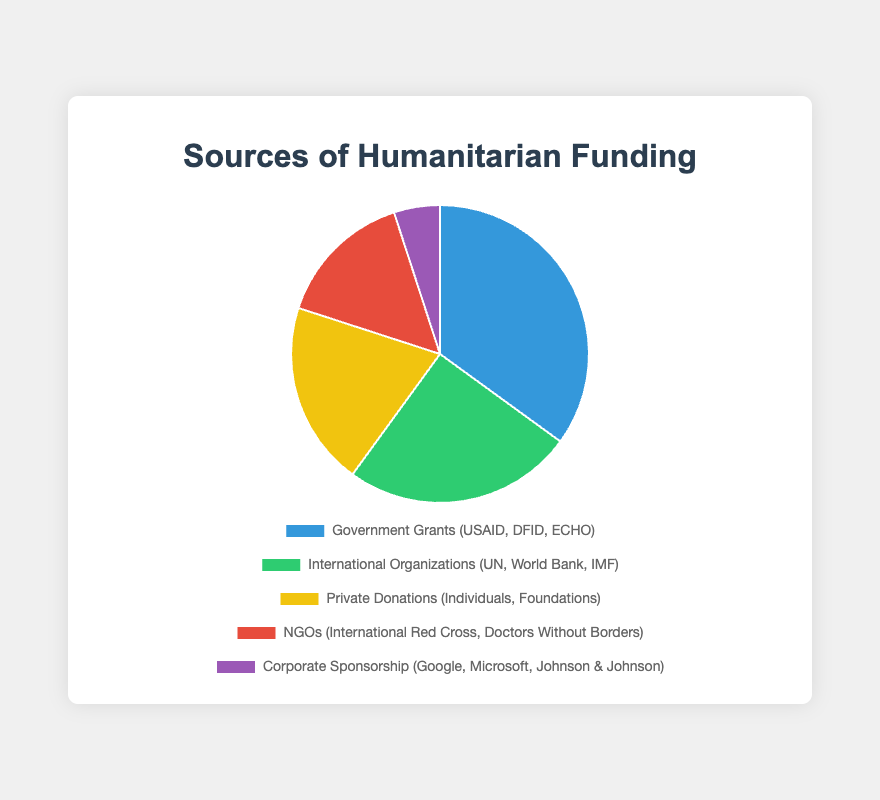Which funding source contributes the largest percentage? Based on the pie chart, look for the section with the largest portion. It's labeled as "Government Grants (USAID, DFID, ECHO)" with 35%.
Answer: Government Grants Which two funding sources combined contribute exactly half of the total funding? Adding the percentages of the two largest sections, "Government Grants (35%)" and "International Organizations (25%)", gives a total of 60%. Instead, adding "Government Grants (35%)" and "Private Donations (20%)" gives a total of 55%. Thus, "International Organizations (25%)" and "Private Donations (20%)" combine to give 45%. Because neither combination adds to exactly 50%, this question needs rephrasing.
Answer: None What is the percentage difference between Private Donations and NGOs? The percentage of Private Donations is 20% and NGOs is 15%. Subtracting 15 from 20 gives 5.
Answer: 5% What percentage of funding comes from non-corporate sources? Summing up the percentages from Government Grants (35%), International Organizations (25%), Private Donations (20%), and NGOs (15%), yields a total of 95%.
Answer: 95% Which funding source has the least contribution and what is its percentage? Look for the smallest section in the pie chart. This is labeled as "Corporate Sponsorship (Google, Microsoft, Johnson & Johnson)" with 5%.
Answer: Corporate Sponsorship, 5% If Government Grants and International Organizations collectively account for 60%, what percentage do the remaining sources represent? Subtract the combined percentage of Government Grants (35%) and International Organizations (25%) from 100%. Thus, 100% - 60% = 40%.
Answer: 40% Which color represents the contributions from NGOs? The pie chart section for NGOs is colored red.
Answer: Red What is the average percentage contribution across all funding sources? Add all the percentages together (35 + 25 + 20 + 15 + 5 = 100), then divide by the number of sources, which is 5. Therefore, 100 / 5 = 20.
Answer: 20% How does the percentage of Private Donations compare to Corporate Sponsorship? The section for Private Donations is 20%, which is greater than the 5% of Corporate Sponsorship.
Answer: Greater How much more does Government Grants contribute compared to Corporate Sponsorship? Subtract the percentage of Corporate Sponsorship (5%) from Government Grants (35%). So, 35 - 5 = 30.
Answer: 30% 